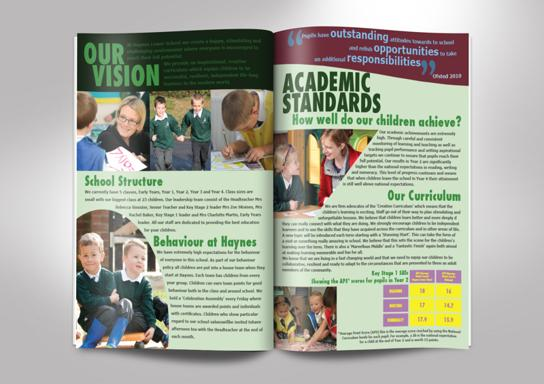Can you tell me more details about the school structure mentioned in the image? The image mentions the school structure within its content but does not delve into detailed descriptions. It likely includes an overview of how educational and administrative operations are handled, hinting at an organized, student-focused approach based on the context surrounding the term in the document. 